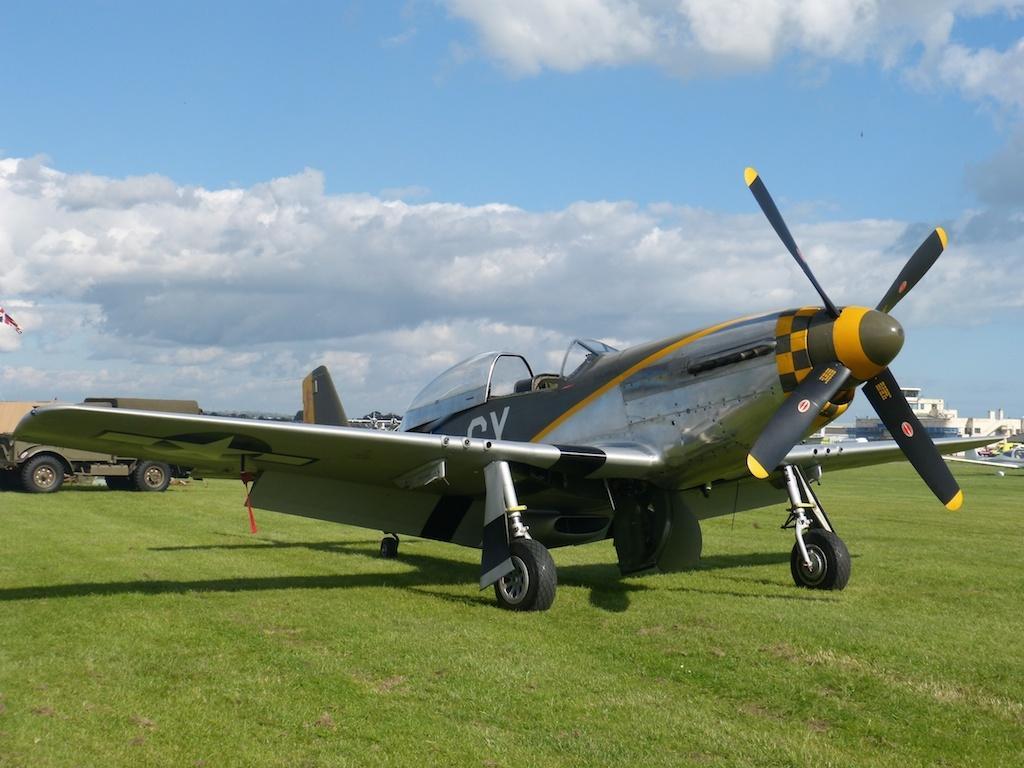Could you give a brief overview of what you see in this image? In this picture there is an aircraft. At the back there is a vehicle and there are buildings and trees. On the left side of the image there is a flag. At the top there is sky and there are clouds. At the bottom there is grass. 